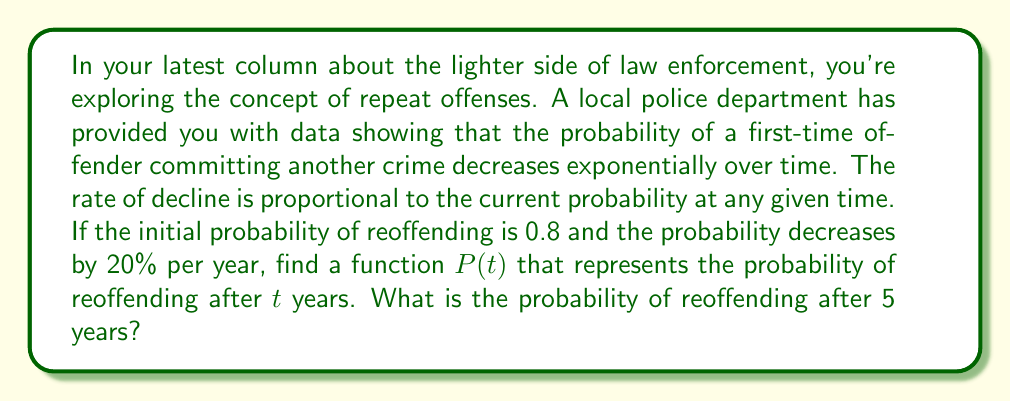Can you solve this math problem? To solve this problem, we need to set up and solve a first-order differential equation:

1) Let $P(t)$ be the probability of reoffending at time $t$.

2) The rate of change of $P$ with respect to $t$ is proportional to $P$ itself:

   $$\frac{dP}{dt} = -kP$$

   where $k$ is a positive constant representing the rate of decline.

3) We're given that the probability decreases by 20% per year, so:

   $$P(1) = 0.8 \cdot (1 - 0.2) = 0.64$$

4) The general solution to the differential equation is:

   $$P(t) = Ce^{-kt}$$

   where $C$ is a constant we need to determine.

5) Using the initial condition $P(0) = 0.8$, we get:

   $$0.8 = Ce^{0} = C$$

6) Now our equation is:

   $$P(t) = 0.8e^{-kt}$$

7) To find $k$, we use the condition from step 3:

   $$0.64 = 0.8e^{-k}$$
   $$0.8 = e^{-k}$$
   $$\ln(0.8) = -k$$
   $$k = -\ln(0.8) \approx 0.223$$

8) Therefore, our final function is:

   $$P(t) = 0.8e^{-0.223t}$$

9) To find the probability after 5 years, we substitute $t=5$:

   $$P(5) = 0.8e^{-0.223 \cdot 5} \approx 0.2466$$
Answer: The function representing the probability of reoffending after $t$ years is:

$$P(t) = 0.8e^{-0.223t}$$

The probability of reoffending after 5 years is approximately 0.2466 or 24.66%. 